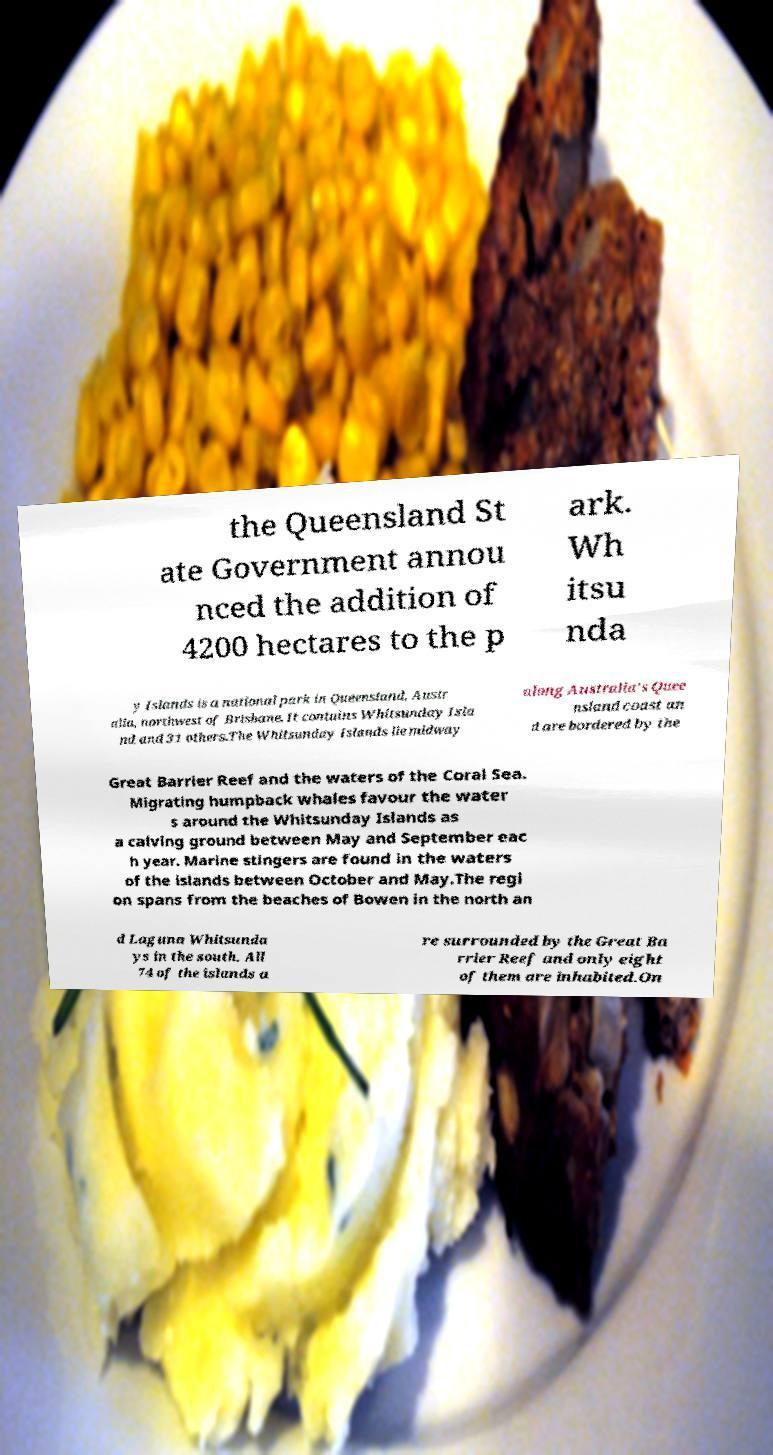Please read and relay the text visible in this image. What does it say? the Queensland St ate Government annou nced the addition of 4200 hectares to the p ark. Wh itsu nda y Islands is a national park in Queensland, Austr alia, northwest of Brisbane. It contains Whitsunday Isla nd and 31 others.The Whitsunday Islands lie midway along Australia's Quee nsland coast an d are bordered by the Great Barrier Reef and the waters of the Coral Sea. Migrating humpback whales favour the water s around the Whitsunday Islands as a calving ground between May and September eac h year. Marine stingers are found in the waters of the islands between October and May.The regi on spans from the beaches of Bowen in the north an d Laguna Whitsunda ys in the south. All 74 of the islands a re surrounded by the Great Ba rrier Reef and only eight of them are inhabited.On 